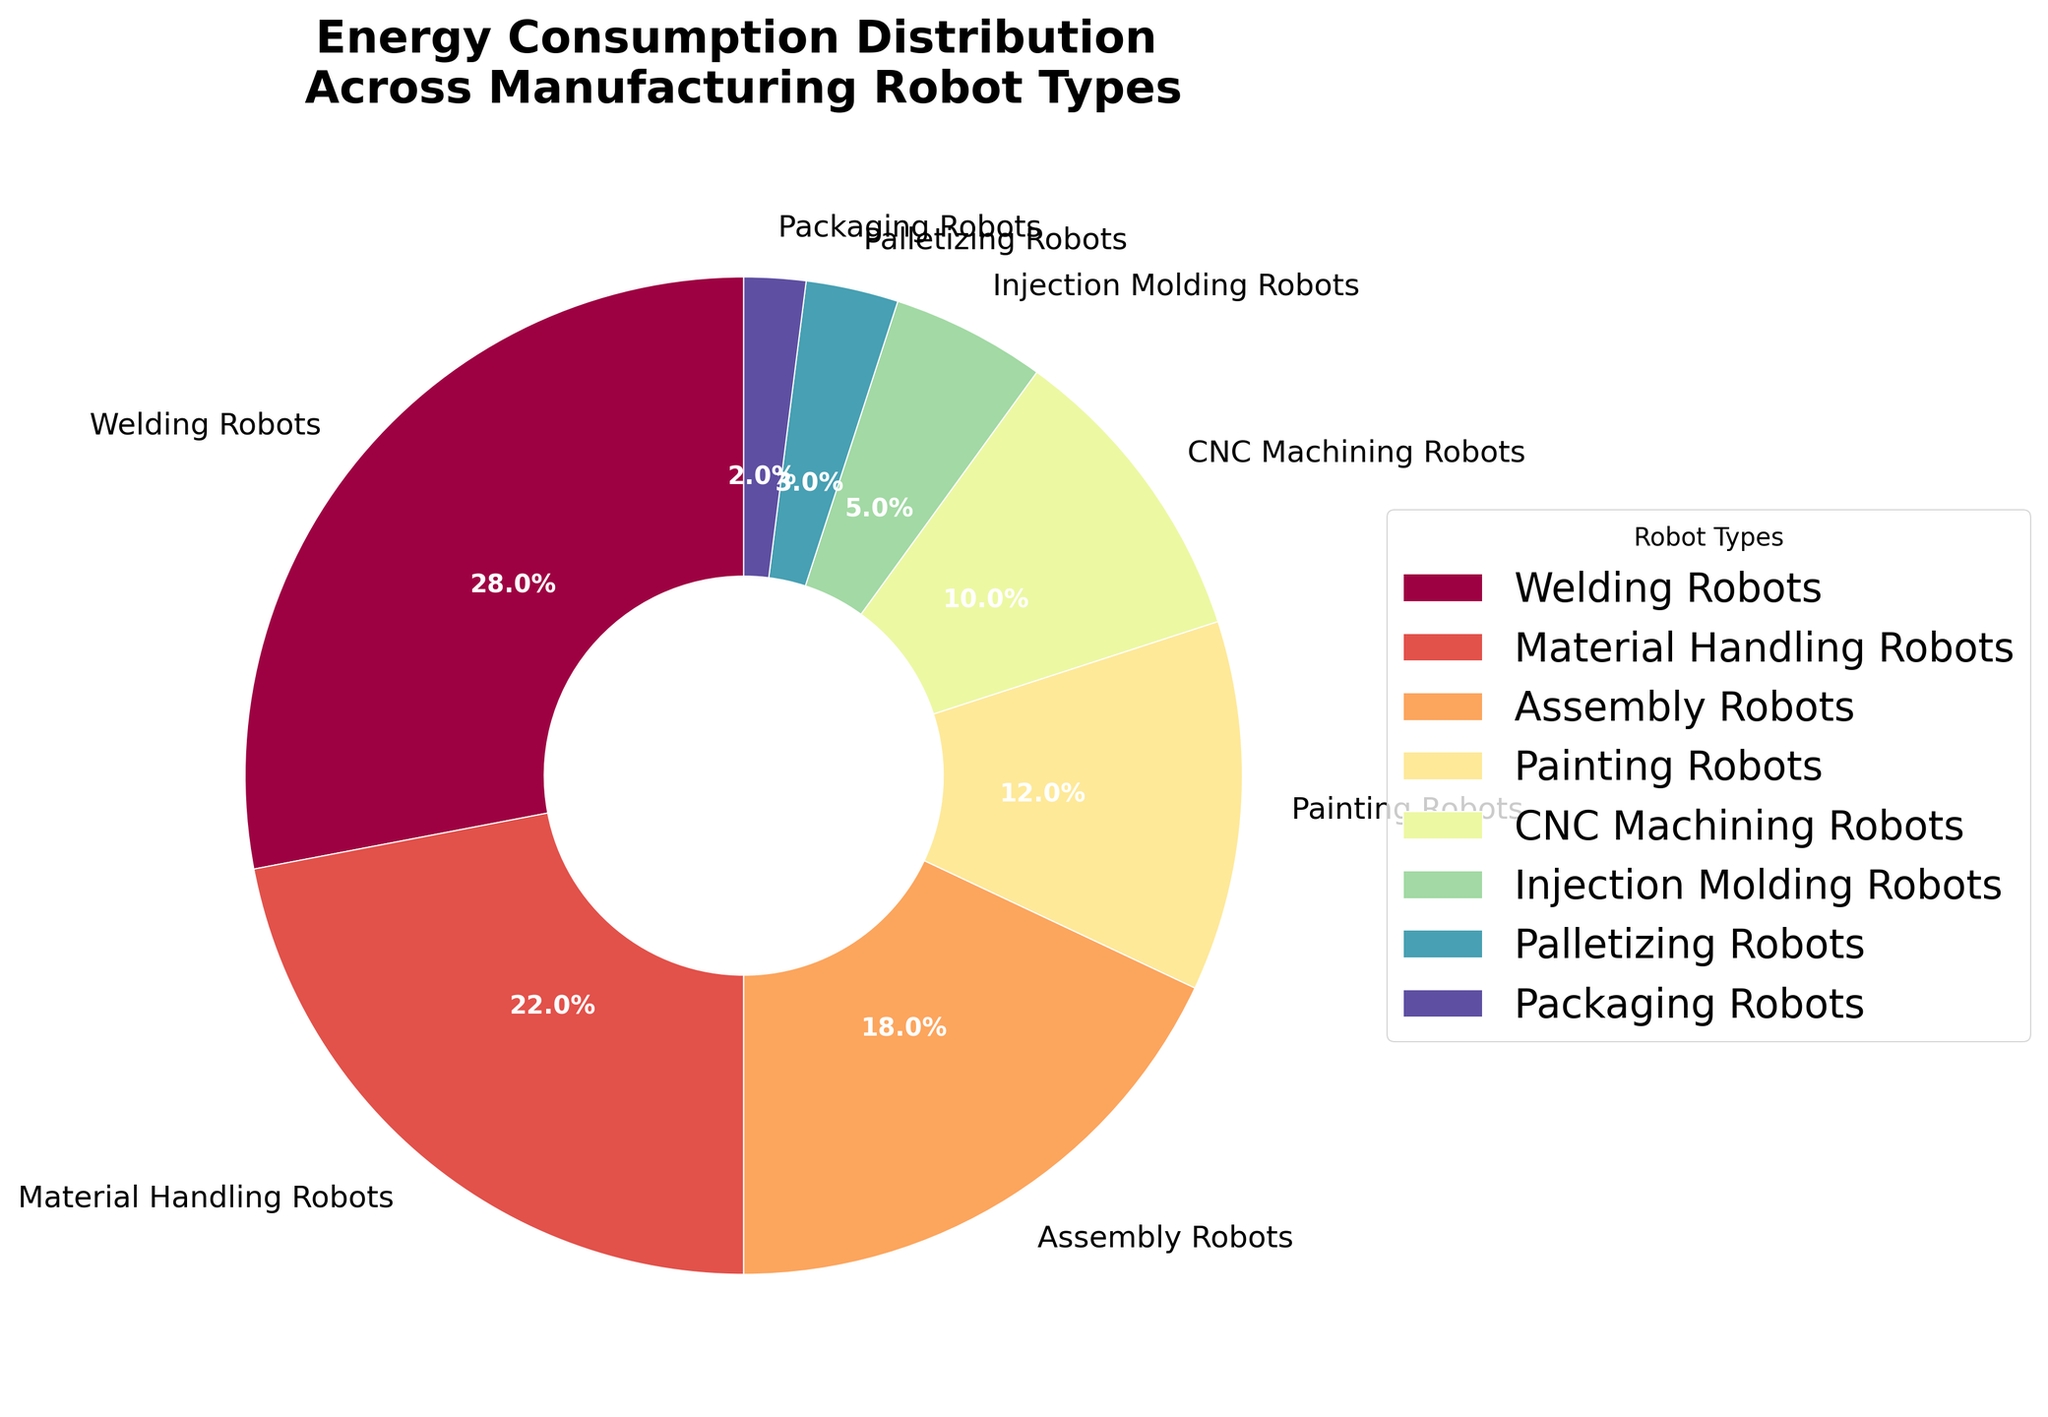Which robot type consumes the most energy? The pie chart shows each robot type's energy consumption in percentage, and the largest wedge represents "Welding Robots" at 28%.
Answer: Welding Robots What is the combined energy consumption of Assembly Robots and Material Handling Robots? The pie chart indicates that Assembly Robots consume 18% and Material Handling Robots consume 22%. Adding these two percentages together gives 18% + 22% = 40%.
Answer: 40% Which robot types together consume less energy than Painting Robots? The pie chart shows that Painting Robots consume 12%. The robot types that consume less individually are Injection Molding Robots (5%), Palletizing Robots (3%), and Packaging Robots (2%). Adding these percentages gives 5% + 3% + 2% = 10%, which is less than 12%.
Answer: Injection Molding Robots, Palletizing Robots, and Packaging Robots How much more energy do Welding Robots consume compared to CNC Machining Robots? Welding Robots consume 28%, while CNC Machining Robots consume 10%. The difference is 28% - 10% = 18%.
Answer: 18% Rank the robot types from highest to lowest energy consumption. The pie chart provides each robot type's energy consumption percentage. By descending order: Welding Robots (28%), Material Handling Robots (22%), Assembly Robots (18%), Painting Robots (12%), CNC Machining Robots (10%), Injection Molding Robots (5%), Palletizing Robots (3%), Packaging Robots (2%).
Answer: Welding Robots, Material Handling Robots, Assembly Robots, Painting Robots, CNC Machining Robots, Injection Molding Robots, Palletizing Robots, Packaging Robots Is the total energy consumption of Painting Robots and Packaging Robots more than the energy consumption of Material Handling Robots? Painting Robots consume 12% and Packaging Robots consume 2%, totaling 14%. Material Handling Robots consume 22%. Since 14% is less than 22%, the total consumption of Painting and Packaging Robots is less.
Answer: No What percentage of energy is consumed by robots not involved in welding or material handling? Welding Robots consume 28% and Material Handling Robots consume 22%. The total energy percentage consumed by these two types is 28% + 22% = 50%. Subtracting this from 100% gives 100% - 50% = 50%.
Answer: 50% Do Assembly Robots consume more energy than CNC Machining and Injection Molding Robots combined? Assembly Robots consume 18%, while CNC Machining Robots consume 10% and Injection Molding Robots consume 5%. Combined, CNC Machining and Injection Molding Robots consume 10% + 5% = 15%. Since 18% is greater than 15%, Assembly Robots consume more energy.
Answer: Yes 